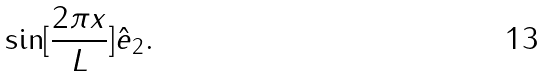<formula> <loc_0><loc_0><loc_500><loc_500>\sin [ \frac { 2 \pi x } { L } ] \hat { e } _ { 2 } .</formula> 